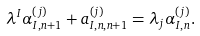Convert formula to latex. <formula><loc_0><loc_0><loc_500><loc_500>\lambda ^ { I } \alpha ^ { ( j ) } _ { I , n + 1 } + a ^ { ( j ) } _ { I , n , n + 1 } = \lambda _ { j } \alpha ^ { ( j ) } _ { I , n } .</formula> 